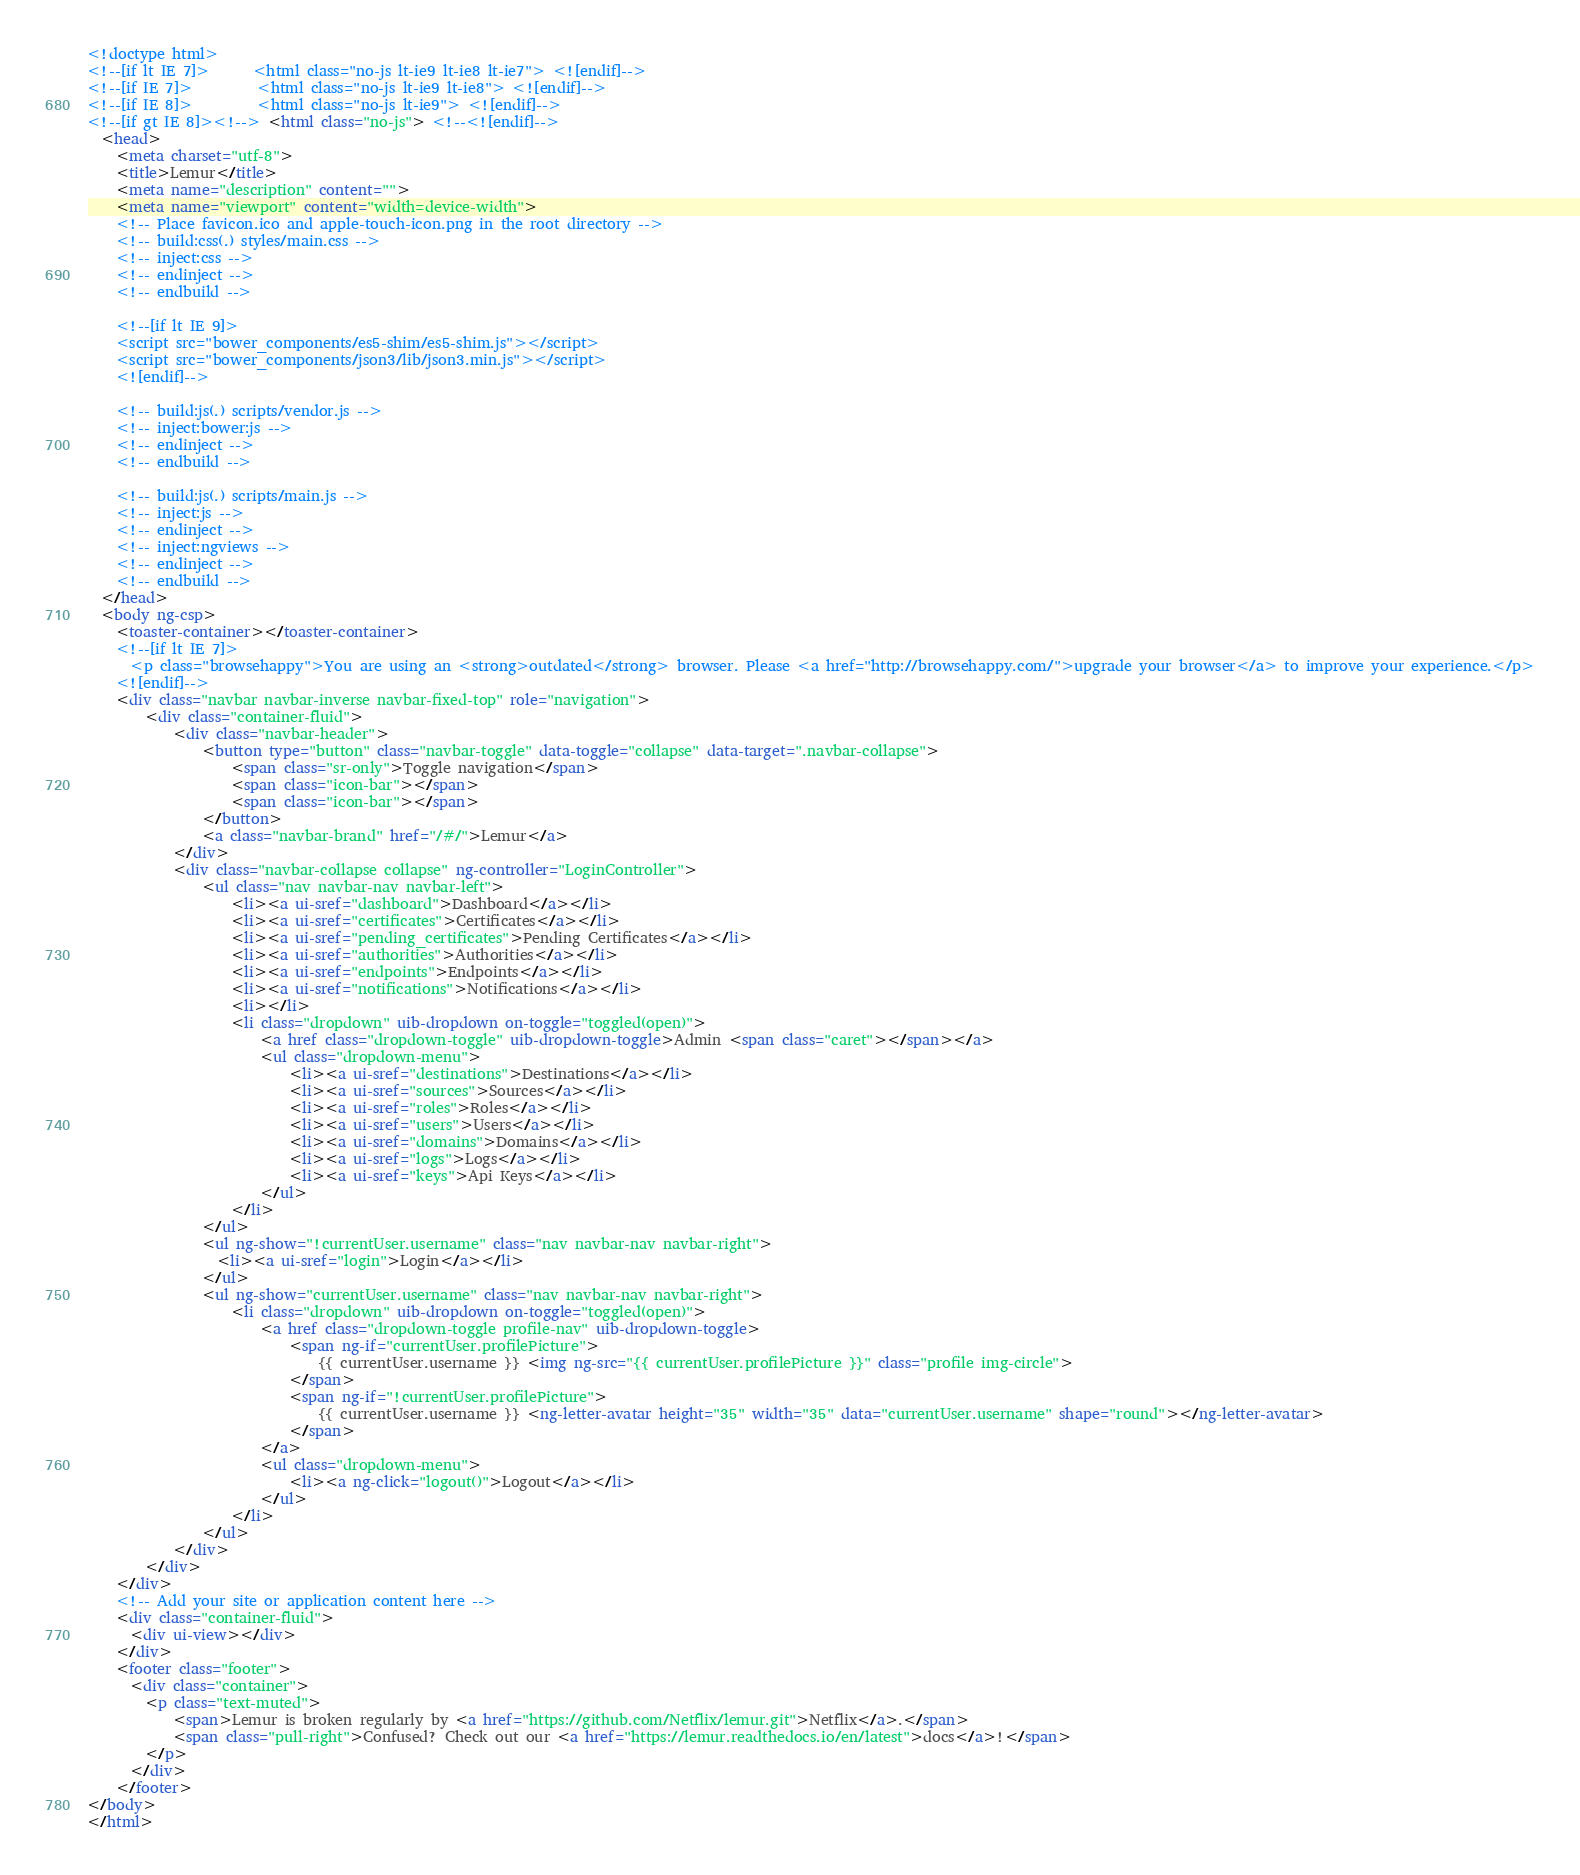Convert code to text. <code><loc_0><loc_0><loc_500><loc_500><_HTML_><!doctype html>
<!--[if lt IE 7]>      <html class="no-js lt-ie9 lt-ie8 lt-ie7"> <![endif]-->
<!--[if IE 7]>         <html class="no-js lt-ie9 lt-ie8"> <![endif]-->
<!--[if IE 8]>         <html class="no-js lt-ie9"> <![endif]-->
<!--[if gt IE 8]><!--> <html class="no-js"> <!--<![endif]-->
  <head>
    <meta charset="utf-8">
    <title>Lemur</title>
    <meta name="description" content="">
    <meta name="viewport" content="width=device-width">
    <!-- Place favicon.ico and apple-touch-icon.png in the root directory -->
    <!-- build:css(.) styles/main.css -->
    <!-- inject:css -->
    <!-- endinject -->
    <!-- endbuild -->

    <!--[if lt IE 9]>
    <script src="bower_components/es5-shim/es5-shim.js"></script>
    <script src="bower_components/json3/lib/json3.min.js"></script>
    <![endif]-->

    <!-- build:js(.) scripts/vendor.js -->
    <!-- inject:bower:js -->
    <!-- endinject -->
    <!-- endbuild -->

    <!-- build:js(.) scripts/main.js -->
    <!-- inject:js -->
    <!-- endinject -->
    <!-- inject:ngviews -->
    <!-- endinject -->
    <!-- endbuild -->
  </head>
  <body ng-csp>
    <toaster-container></toaster-container>
    <!--[if lt IE 7]>
      <p class="browsehappy">You are using an <strong>outdated</strong> browser. Please <a href="http://browsehappy.com/">upgrade your browser</a> to improve your experience.</p>
    <![endif]-->
    <div class="navbar navbar-inverse navbar-fixed-top" role="navigation">
        <div class="container-fluid">
            <div class="navbar-header">
                <button type="button" class="navbar-toggle" data-toggle="collapse" data-target=".navbar-collapse">
                    <span class="sr-only">Toggle navigation</span>
                    <span class="icon-bar"></span>
                    <span class="icon-bar"></span>
                </button>
                <a class="navbar-brand" href="/#/">Lemur</a>
            </div>
            <div class="navbar-collapse collapse" ng-controller="LoginController">
                <ul class="nav navbar-nav navbar-left">
                    <li><a ui-sref="dashboard">Dashboard</a></li>
                    <li><a ui-sref="certificates">Certificates</a></li>
                    <li><a ui-sref="pending_certificates">Pending Certificates</a></li>
                    <li><a ui-sref="authorities">Authorities</a></li>
                    <li><a ui-sref="endpoints">Endpoints</a></li>
                    <li><a ui-sref="notifications">Notifications</a></li>
                    <li></li>
                    <li class="dropdown" uib-dropdown on-toggle="toggled(open)">
                        <a href class="dropdown-toggle" uib-dropdown-toggle>Admin <span class="caret"></span></a>
                        <ul class="dropdown-menu">
                            <li><a ui-sref="destinations">Destinations</a></li>
                            <li><a ui-sref="sources">Sources</a></li>
                            <li><a ui-sref="roles">Roles</a></li>
                            <li><a ui-sref="users">Users</a></li>
                            <li><a ui-sref="domains">Domains</a></li>
                            <li><a ui-sref="logs">Logs</a></li>
                            <li><a ui-sref="keys">Api Keys</a></li>
                        </ul>
                    </li>
                </ul>
                <ul ng-show="!currentUser.username" class="nav navbar-nav navbar-right">
                  <li><a ui-sref="login">Login</a></li>
                </ul>
                <ul ng-show="currentUser.username" class="nav navbar-nav navbar-right">
                    <li class="dropdown" uib-dropdown on-toggle="toggled(open)">
                        <a href class="dropdown-toggle profile-nav" uib-dropdown-toggle>
                            <span ng-if="currentUser.profilePicture">
                                {{ currentUser.username }} <img ng-src="{{ currentUser.profilePicture }}" class="profile img-circle">
                            </span>
                            <span ng-if="!currentUser.profilePicture">
                                {{ currentUser.username }} <ng-letter-avatar height="35" width="35" data="currentUser.username" shape="round"></ng-letter-avatar>
                            </span>
                        </a>
                        <ul class="dropdown-menu">
                            <li><a ng-click="logout()">Logout</a></li>
                        </ul>
                    </li>
                </ul>
            </div>
        </div>
    </div>
    <!-- Add your site or application content here -->
    <div class="container-fluid">
      <div ui-view></div>
    </div>
    <footer class="footer">
      <div class="container">
        <p class="text-muted">
            <span>Lemur is broken regularly by <a href="https://github.com/Netflix/lemur.git">Netflix</a>.</span>
            <span class="pull-right">Confused? Check out our <a href="https://lemur.readthedocs.io/en/latest">docs</a>!</span>
        </p>
      </div>
    </footer>
</body>
</html>
</code> 